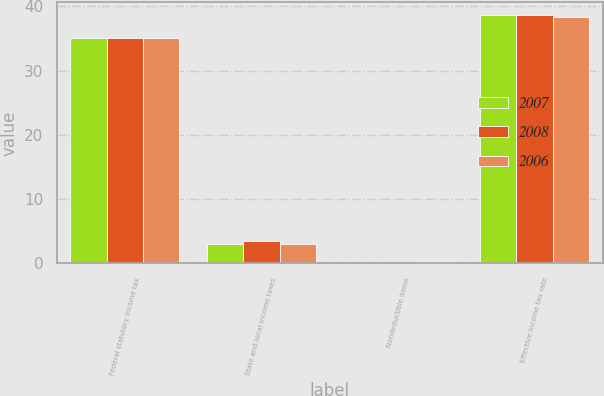<chart> <loc_0><loc_0><loc_500><loc_500><stacked_bar_chart><ecel><fcel>Federal statutory income tax<fcel>State and local income taxes<fcel>Nondeductible items<fcel>Effective income tax rate<nl><fcel>2007<fcel>35<fcel>3.1<fcel>0.1<fcel>38.7<nl><fcel>2008<fcel>35<fcel>3.5<fcel>0.1<fcel>38.6<nl><fcel>2006<fcel>35<fcel>3<fcel>0.3<fcel>38.3<nl></chart> 